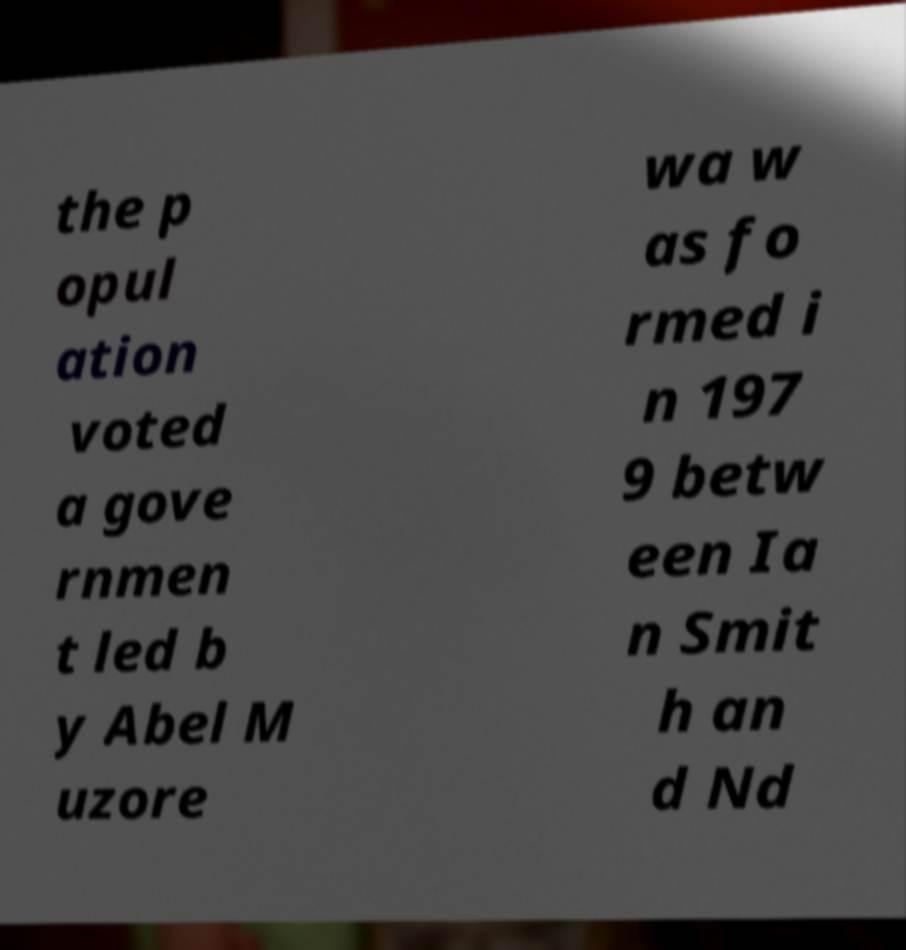What messages or text are displayed in this image? I need them in a readable, typed format. the p opul ation voted a gove rnmen t led b y Abel M uzore wa w as fo rmed i n 197 9 betw een Ia n Smit h an d Nd 